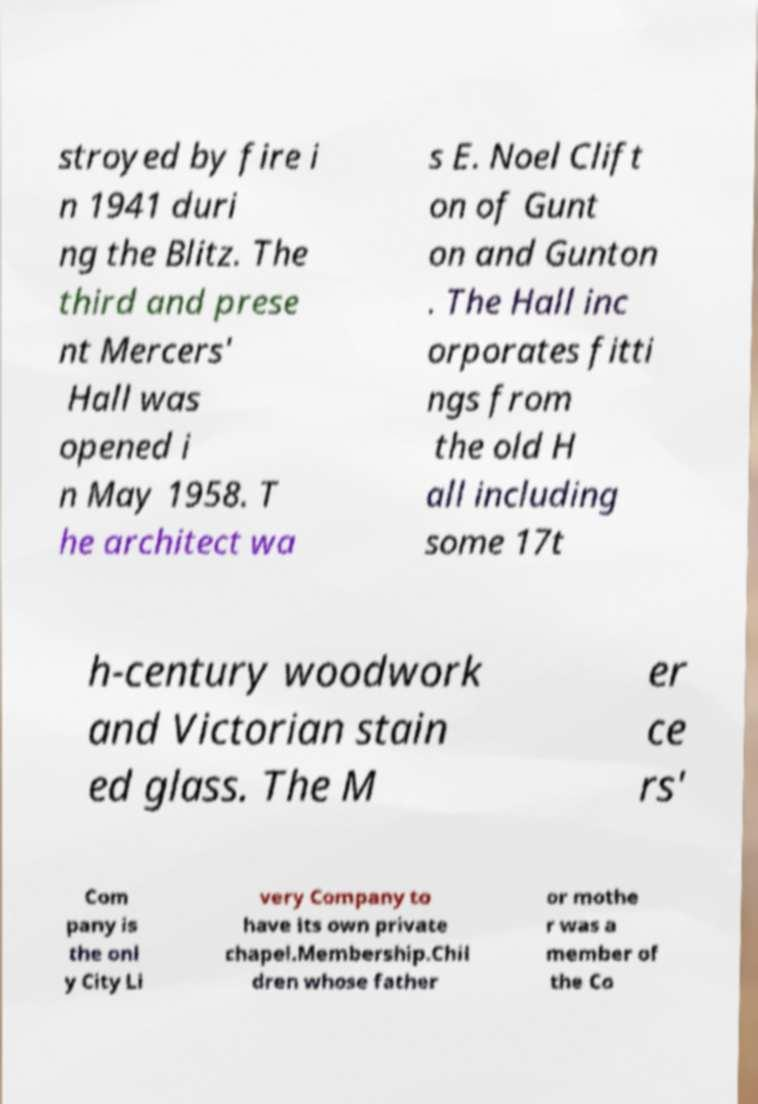There's text embedded in this image that I need extracted. Can you transcribe it verbatim? stroyed by fire i n 1941 duri ng the Blitz. The third and prese nt Mercers' Hall was opened i n May 1958. T he architect wa s E. Noel Clift on of Gunt on and Gunton . The Hall inc orporates fitti ngs from the old H all including some 17t h-century woodwork and Victorian stain ed glass. The M er ce rs' Com pany is the onl y City Li very Company to have its own private chapel.Membership.Chil dren whose father or mothe r was a member of the Co 